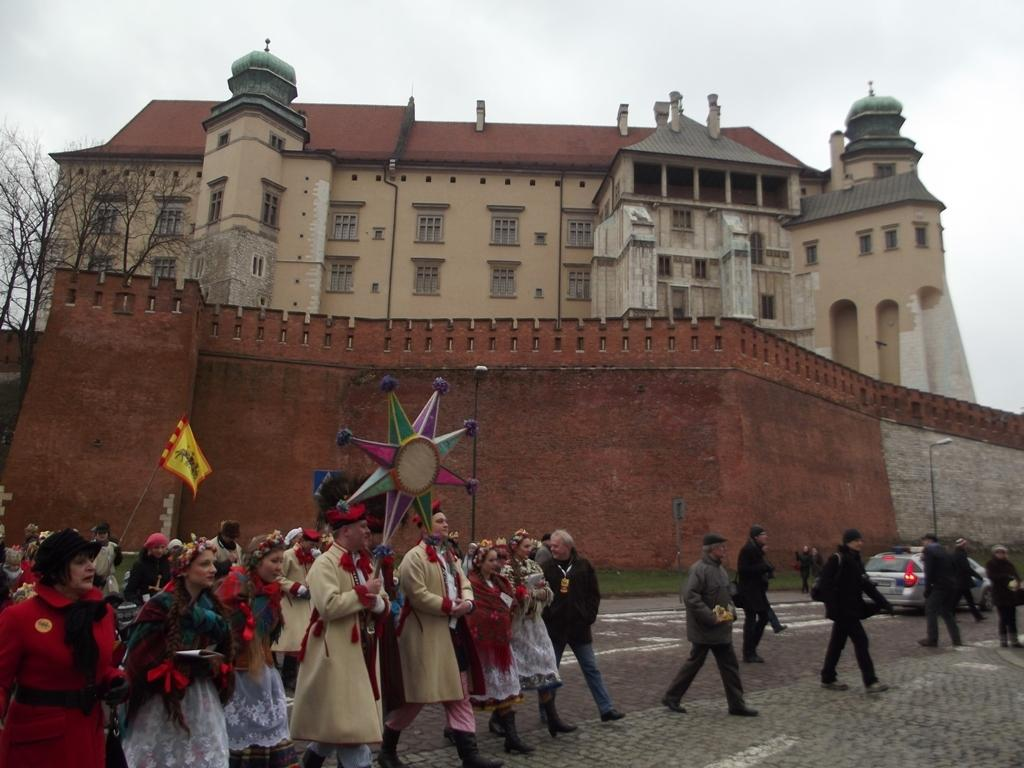What type of structure is visible in the image? There is a building with windows in the image. What is located in front of the building? There are trees and a wall in front of the building. What can be seen illuminating the area in the image? There are light poles in the image. Who or what is present in the image? People and a vehicle are visible in the image. What is the man in the image doing? A man is holding a flag in the image. What type of steel is used to construct the building in the image? There is no information about the type of steel used to construct the building in the image. Is there an ongoing attack in the image? There is no indication of an attack in the image. 